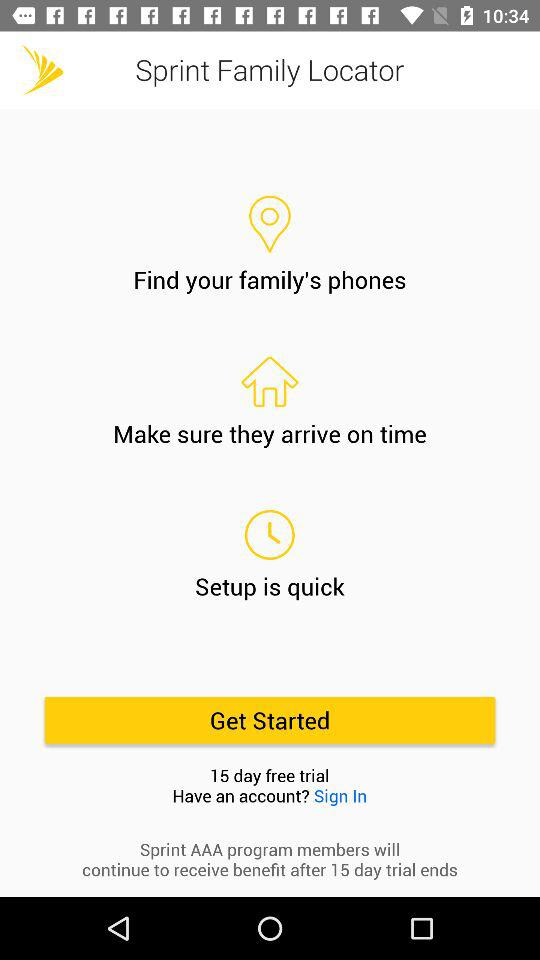What is the duration of the free trial? The duration of the free trial is 15 days. 